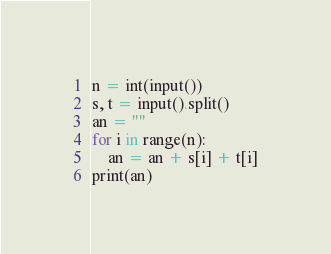Convert code to text. <code><loc_0><loc_0><loc_500><loc_500><_Python_>n = int(input())
s, t = input().split()
an = ""
for i in range(n):
    an = an + s[i] + t[i]
print(an)
</code> 